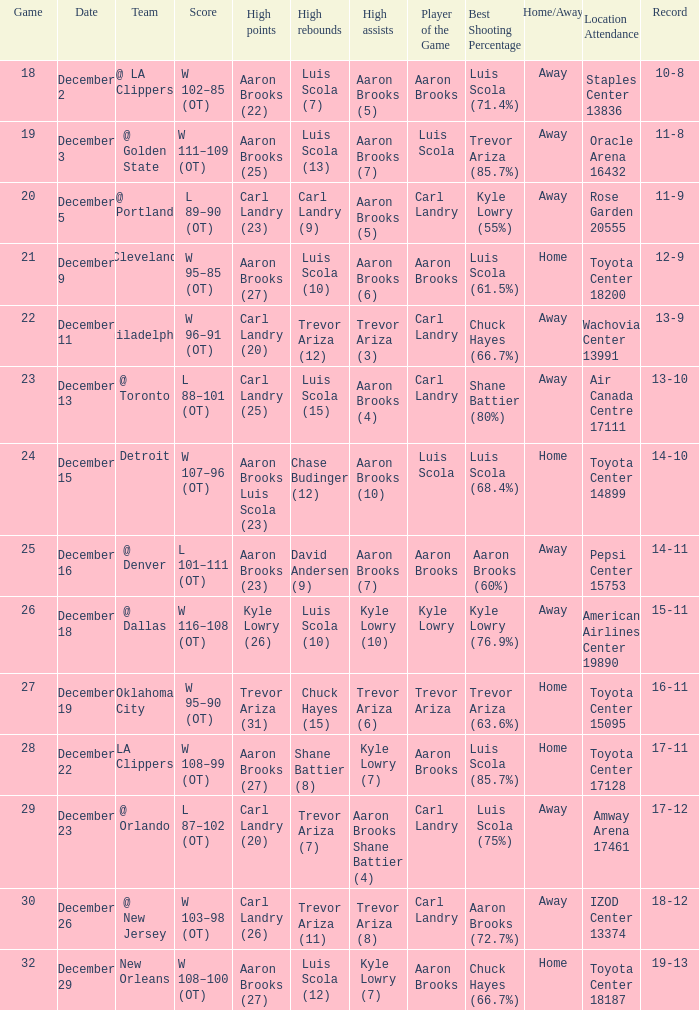Who did the high rebounds in the game where Carl Landry (23) did the most high points? Carl Landry (9). 